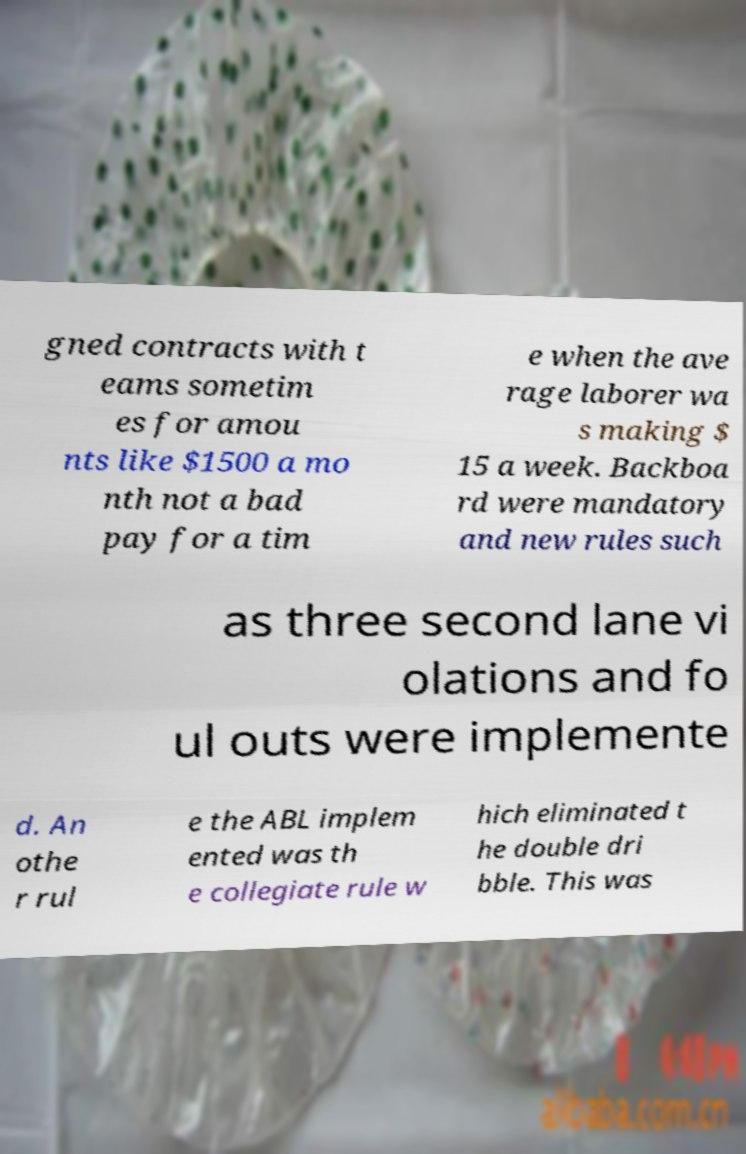What messages or text are displayed in this image? I need them in a readable, typed format. gned contracts with t eams sometim es for amou nts like $1500 a mo nth not a bad pay for a tim e when the ave rage laborer wa s making $ 15 a week. Backboa rd were mandatory and new rules such as three second lane vi olations and fo ul outs were implemente d. An othe r rul e the ABL implem ented was th e collegiate rule w hich eliminated t he double dri bble. This was 